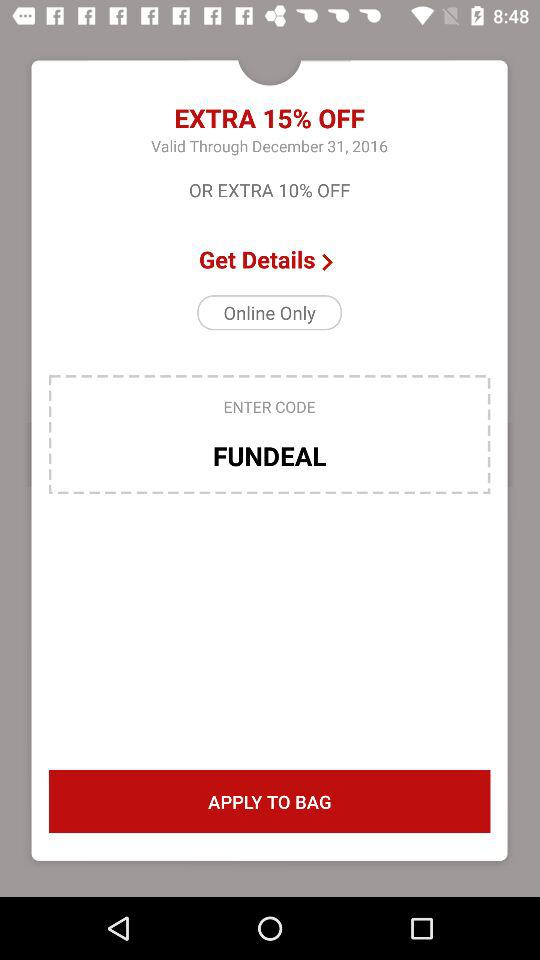What is the entered code? The entered code is FUNDEAL. 